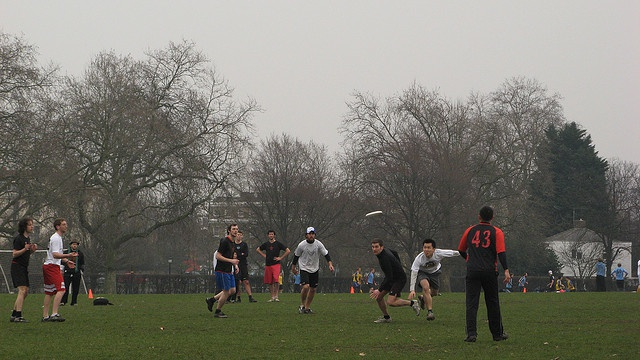Describe the objects in this image and their specific colors. I can see people in lightgray, black, maroon, darkgreen, and brown tones, people in lightgray, black, gray, and darkgreen tones, people in lightgray, maroon, gray, and black tones, people in lightgray, black, darkgreen, and gray tones, and people in lightgray, black, gray, and maroon tones in this image. 